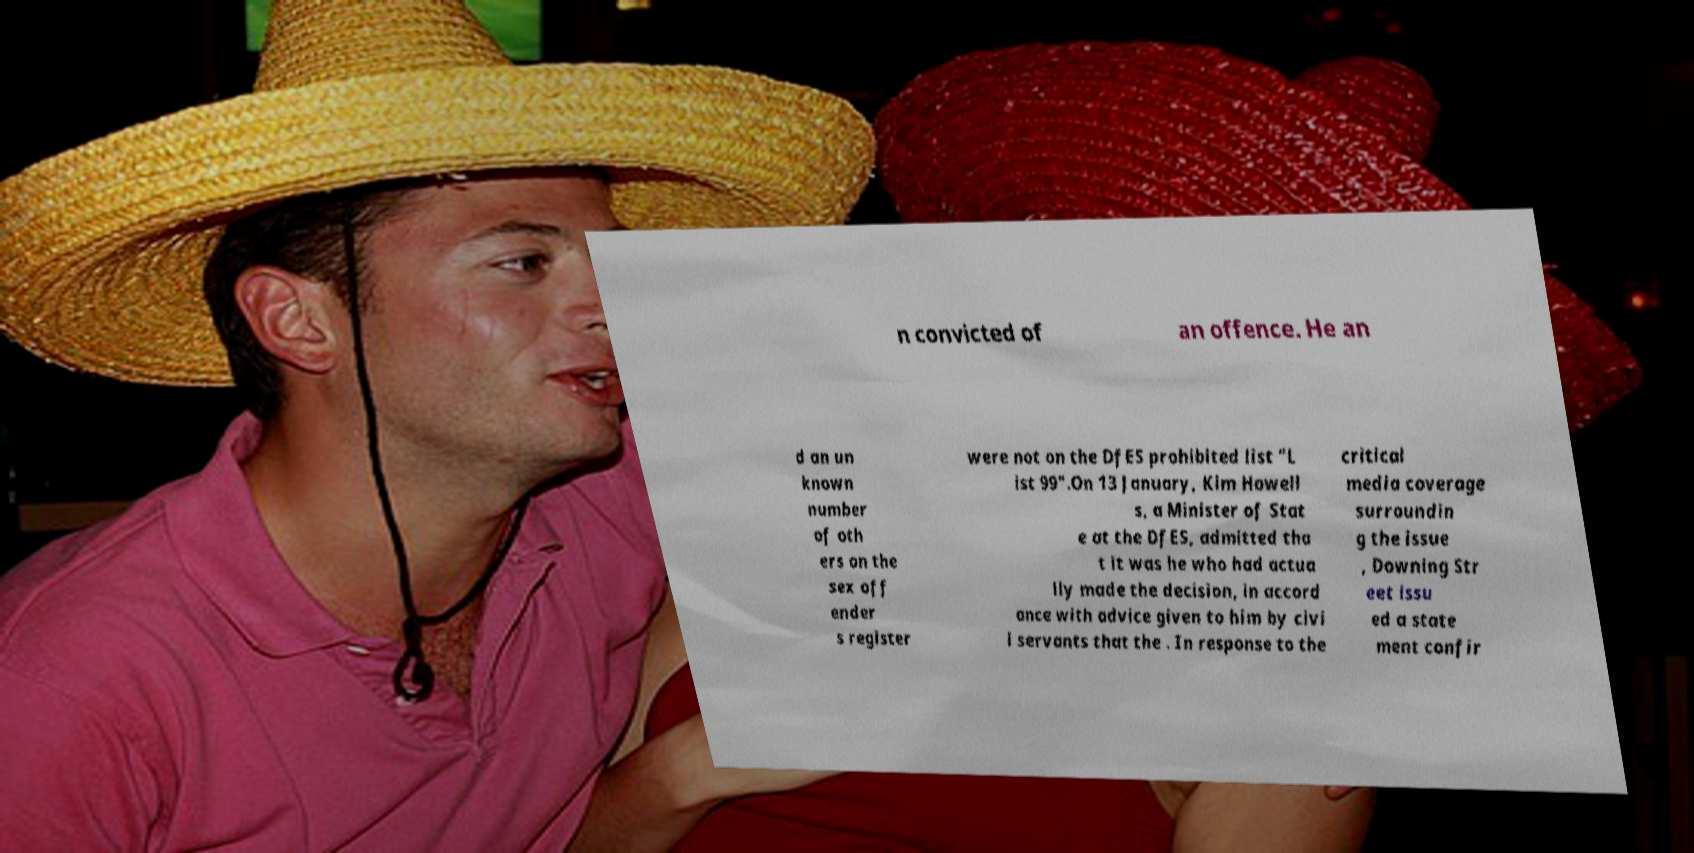I need the written content from this picture converted into text. Can you do that? n convicted of an offence. He an d an un known number of oth ers on the sex off ender s register were not on the DfES prohibited list "L ist 99".On 13 January, Kim Howell s, a Minister of Stat e at the DfES, admitted tha t it was he who had actua lly made the decision, in accord ance with advice given to him by civi l servants that the . In response to the critical media coverage surroundin g the issue , Downing Str eet issu ed a state ment confir 